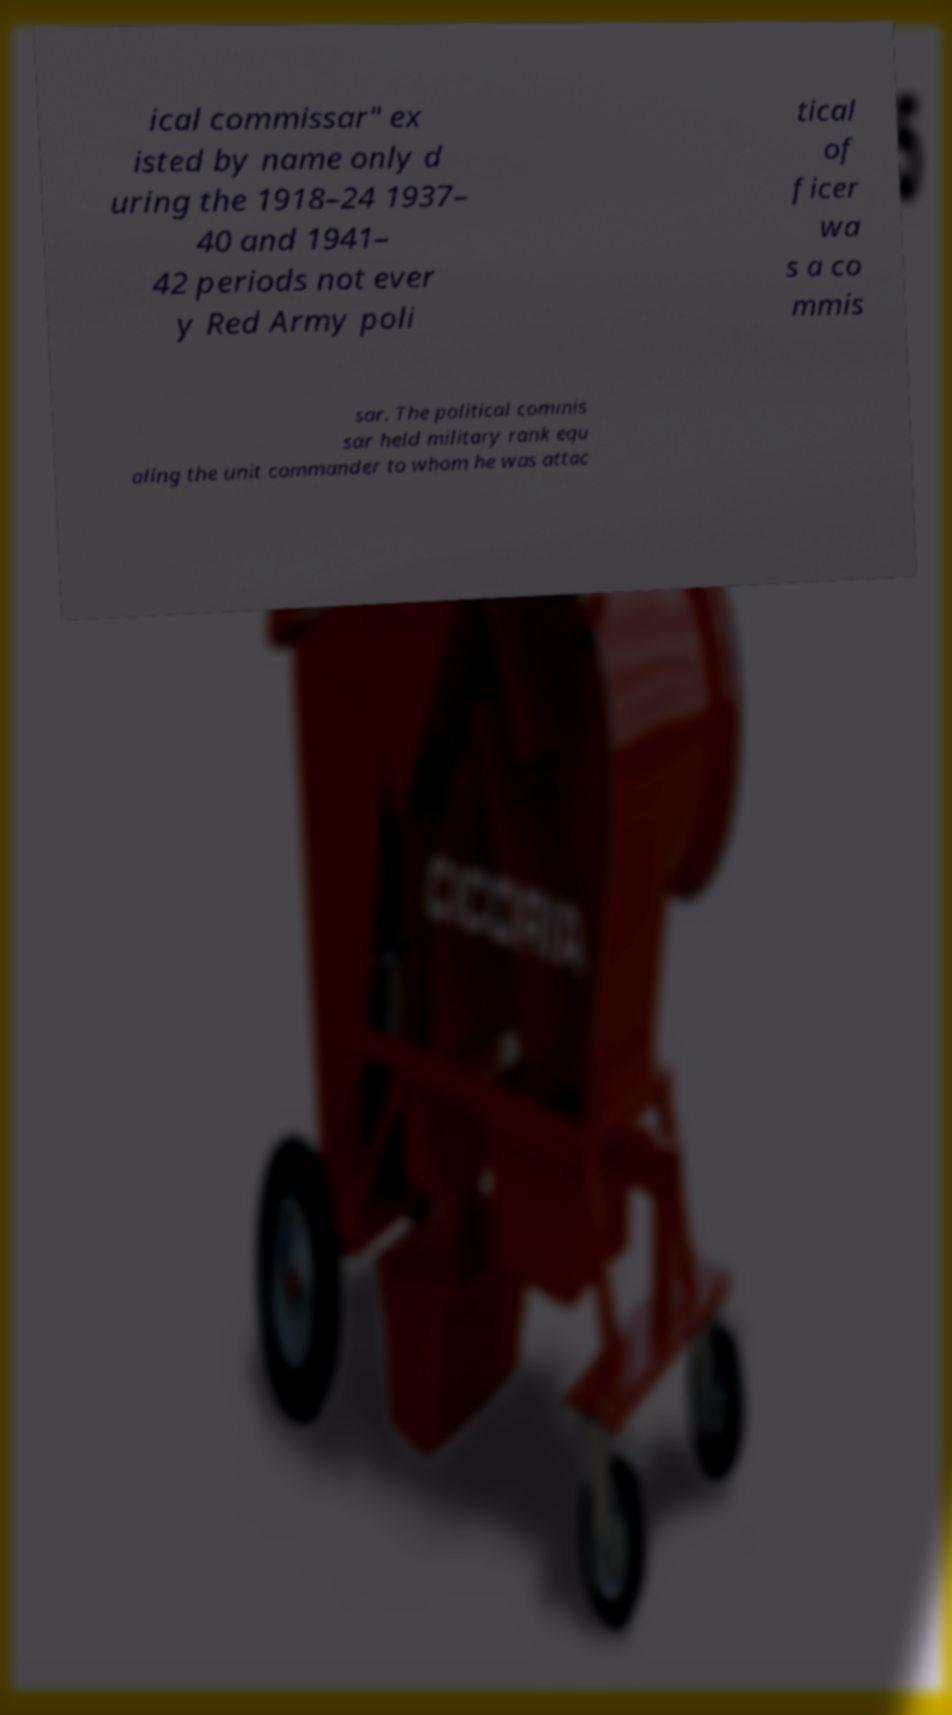Can you accurately transcribe the text from the provided image for me? ical commissar" ex isted by name only d uring the 1918–24 1937– 40 and 1941– 42 periods not ever y Red Army poli tical of ficer wa s a co mmis sar. The political commis sar held military rank equ aling the unit commander to whom he was attac 